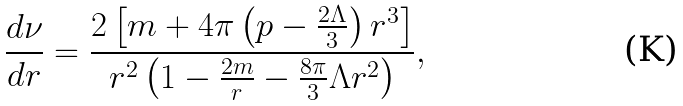<formula> <loc_0><loc_0><loc_500><loc_500>\frac { d \nu } { d r } = \frac { 2 \left [ m + 4 \pi \left ( p - \frac { 2 \Lambda } { 3 } \right ) r ^ { 3 } \right ] } { r ^ { 2 } \left ( 1 - \frac { 2 m } { r } - \frac { 8 \pi } { 3 } \Lambda r ^ { 2 } \right ) } ,</formula> 